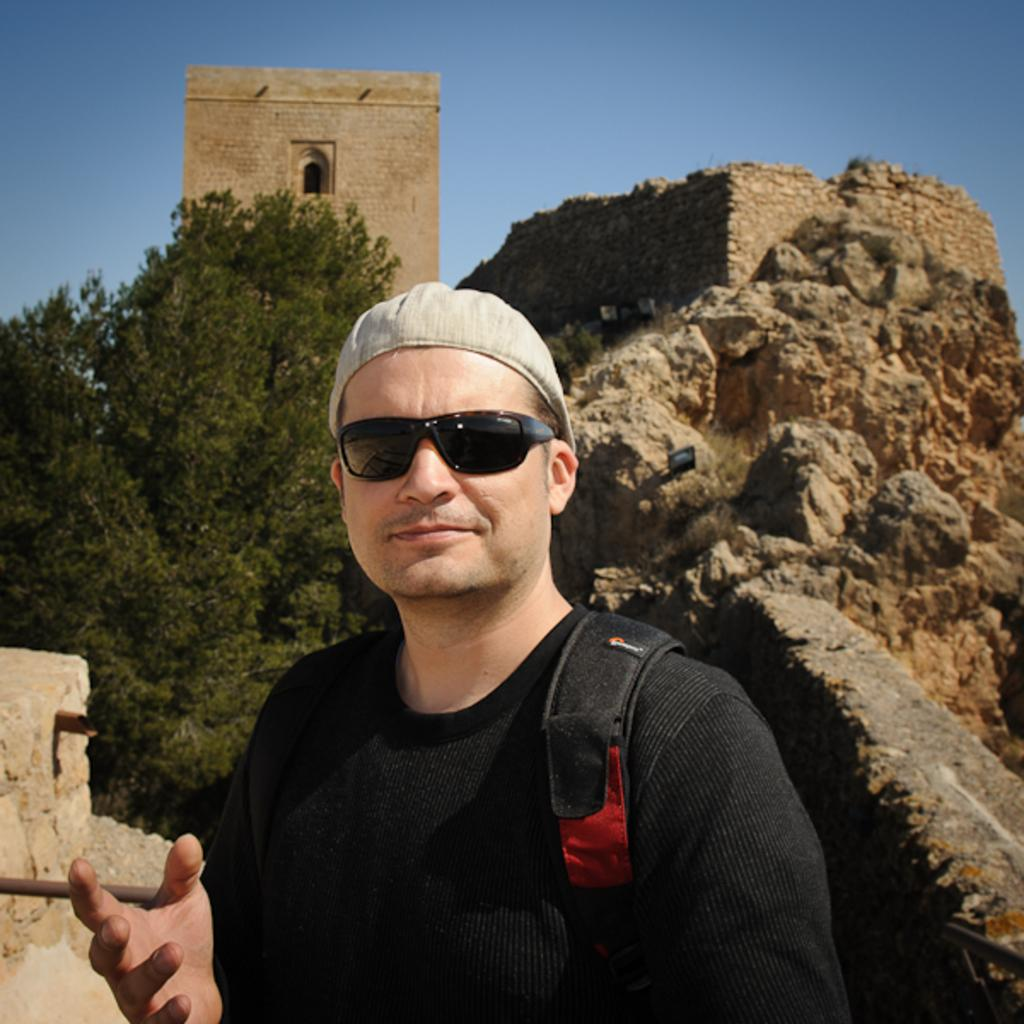Who is present in the image? There is a man in the image. What is the man wearing on his face? The man is wearing spectacles. What is the man carrying in the image? The man has a bag. What color is the t-shirt the man is wearing? The man is wearing a black color t-shirt. What can be seen in the background of the image? There are trees, a building, a rock, and the sky visible in the background of the image. What type of plant is the man giving advice to in the image? There is no plant present in the image, nor is the man giving any advice. 